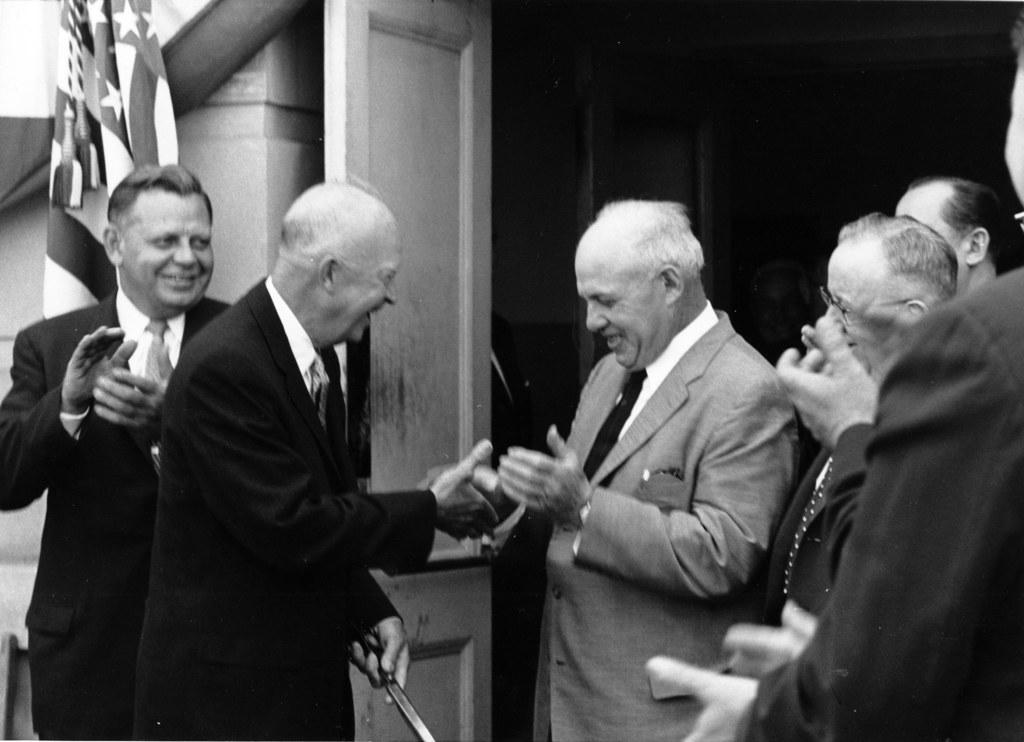How many people are in the image? There is a group of people in the image. What are the people doing in the image? The people are standing and smiling. What can be seen in the background of the image? There is a flag and a door in the background of the image. How would you describe the lighting in the image? The background of the image is dark. Where is the nearest volcano to the people in the image? There is no volcano present in the image, so it is not possible to determine its proximity to the people. 